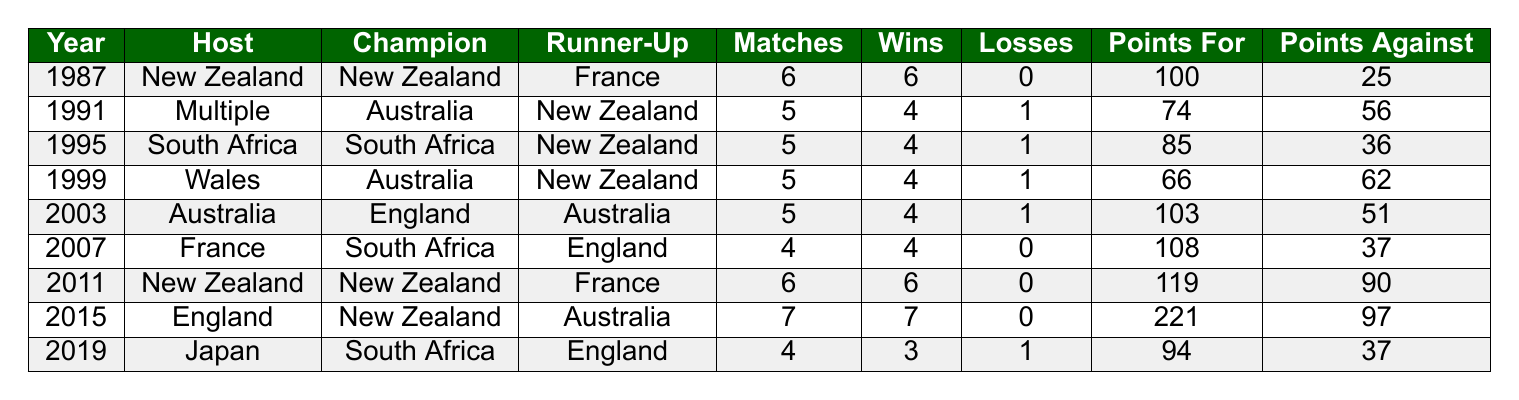What year did New Zealand first win the Rugby World Cup? By looking at the table, the first year listed is 1987, which shows that New Zealand was the champion.
Answer: 1987 How many matches did New Zealand play in the 2015 Rugby World Cup? Looking at the row for the year 2015, it is stated that New Zealand played 7 matches.
Answer: 7 In which year did New Zealand have the most points scored in the Rugby World Cup? Reviewing the "Points For" column, in 2015, New Zealand scored 221 points, which is the highest in the list.
Answer: 2015 Did New Zealand lose any matches in the 1987 Rugby World Cup? In the row for 1987, it shows that New Zealand had 0 losses, indicating they did not lose any matches that tournament.
Answer: No What was the average number of wins for New Zealand across the years they were champions? New Zealand was champion in 1987, 2011, and 2015. They had 6 wins in 1987, 6 wins in 2011, and 7 wins in 2015. So, average is (6 + 6 + 7) / 3 = 19 / 3 = approximately 6.33.
Answer: 6.33 In which tournaments did New Zealand finish as the runner-up? By checking each row for New Zealand as the runner-up, we find they placed second in the years 1991, 1995, and 1999.
Answer: 1991, 1995, 1999 How many total losses did New Zealand incur in all the listed Rugby World Cups? Adding up all the losses: 0 (1987) + 1 (1991) + 1 (1995) + 1 (1999) + 1 (2003) + 0 (2007) + 0 (2011) + 0 (2015) + 1 (2019) = 5 total losses.
Answer: 5 Which host nation had New Zealand as the champion? Referring to the table, New Zealand was the champion when the Rugby World Cups took place in New Zealand in 1987 and 2011.
Answer: New Zealand Did the losing team in 1995 score more points than New Zealand? The table shows that in 1995, South Africa (the champion) scored 85 points and New Zealand (the runner-up) scored 36 points. Therefore, South Africa scored more points than New Zealand.
Answer: Yes 